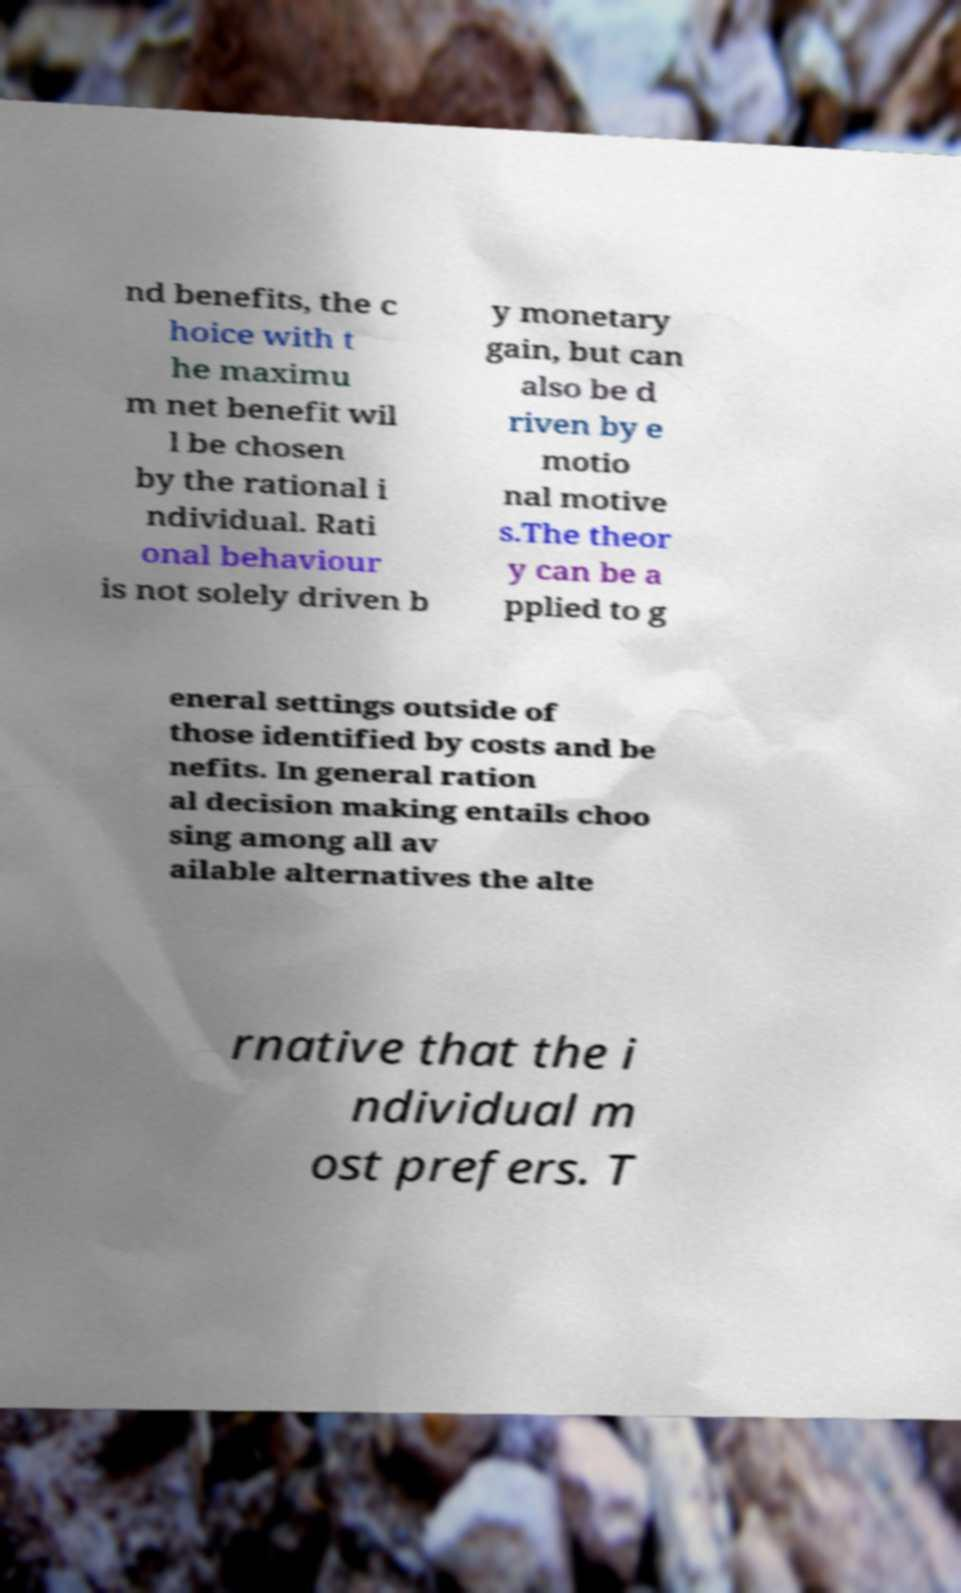There's text embedded in this image that I need extracted. Can you transcribe it verbatim? nd benefits, the c hoice with t he maximu m net benefit wil l be chosen by the rational i ndividual. Rati onal behaviour is not solely driven b y monetary gain, but can also be d riven by e motio nal motive s.The theor y can be a pplied to g eneral settings outside of those identified by costs and be nefits. In general ration al decision making entails choo sing among all av ailable alternatives the alte rnative that the i ndividual m ost prefers. T 